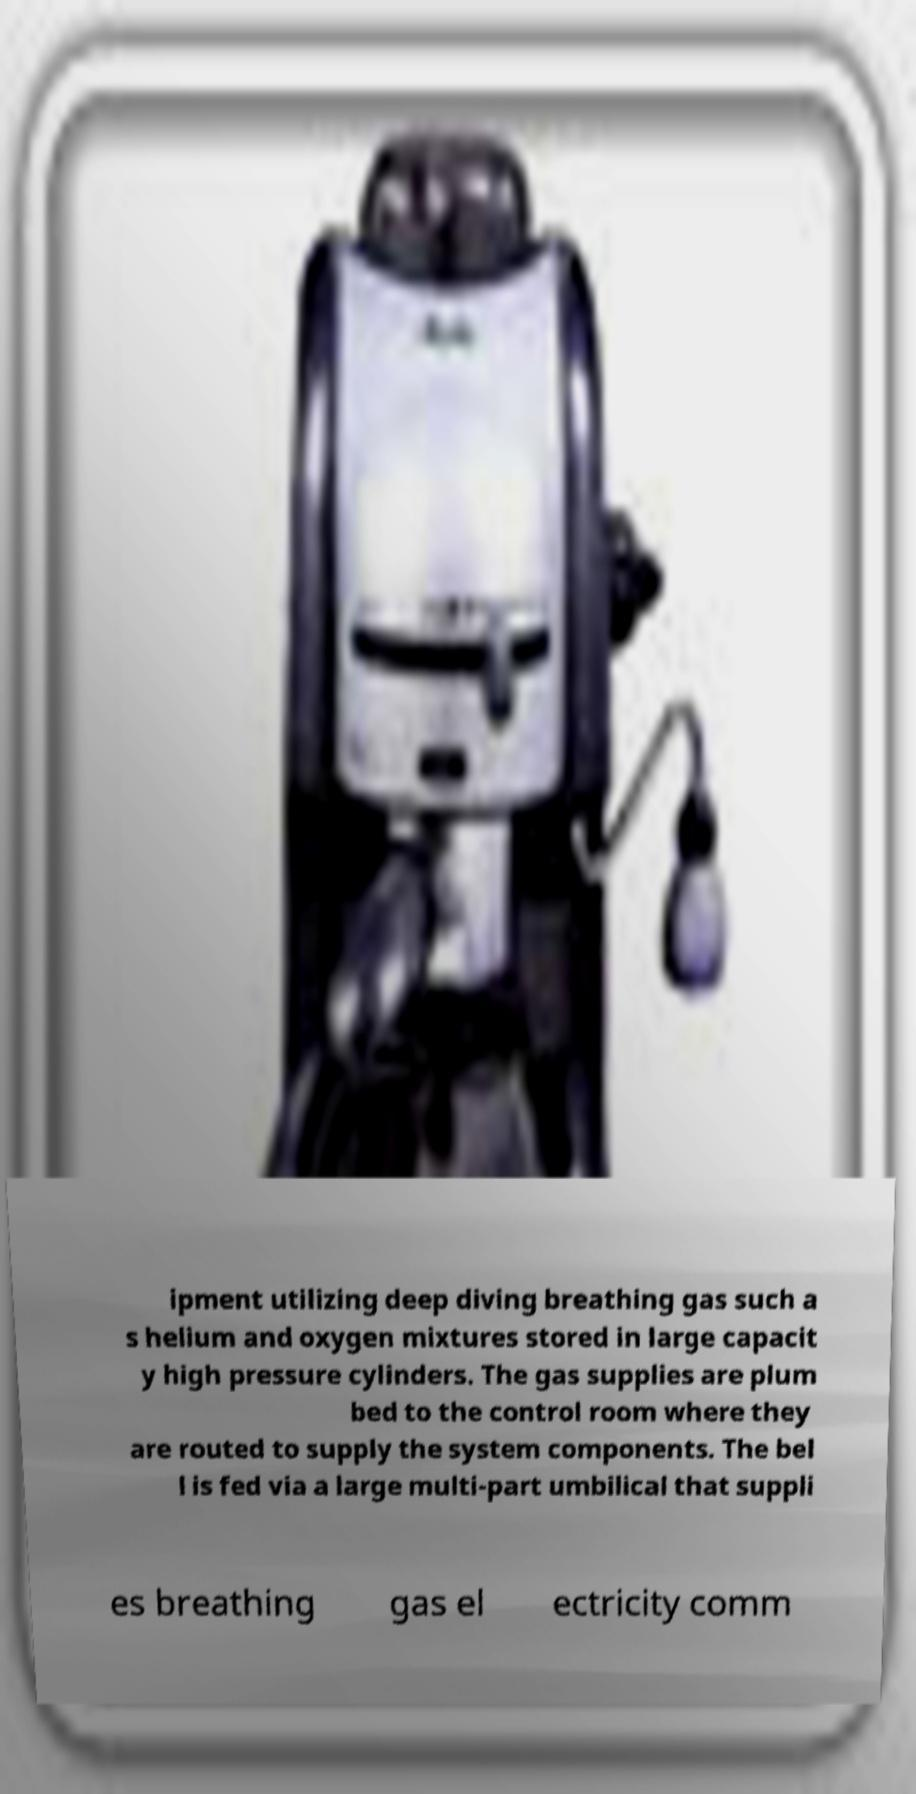Can you accurately transcribe the text from the provided image for me? ipment utilizing deep diving breathing gas such a s helium and oxygen mixtures stored in large capacit y high pressure cylinders. The gas supplies are plum bed to the control room where they are routed to supply the system components. The bel l is fed via a large multi-part umbilical that suppli es breathing gas el ectricity comm 